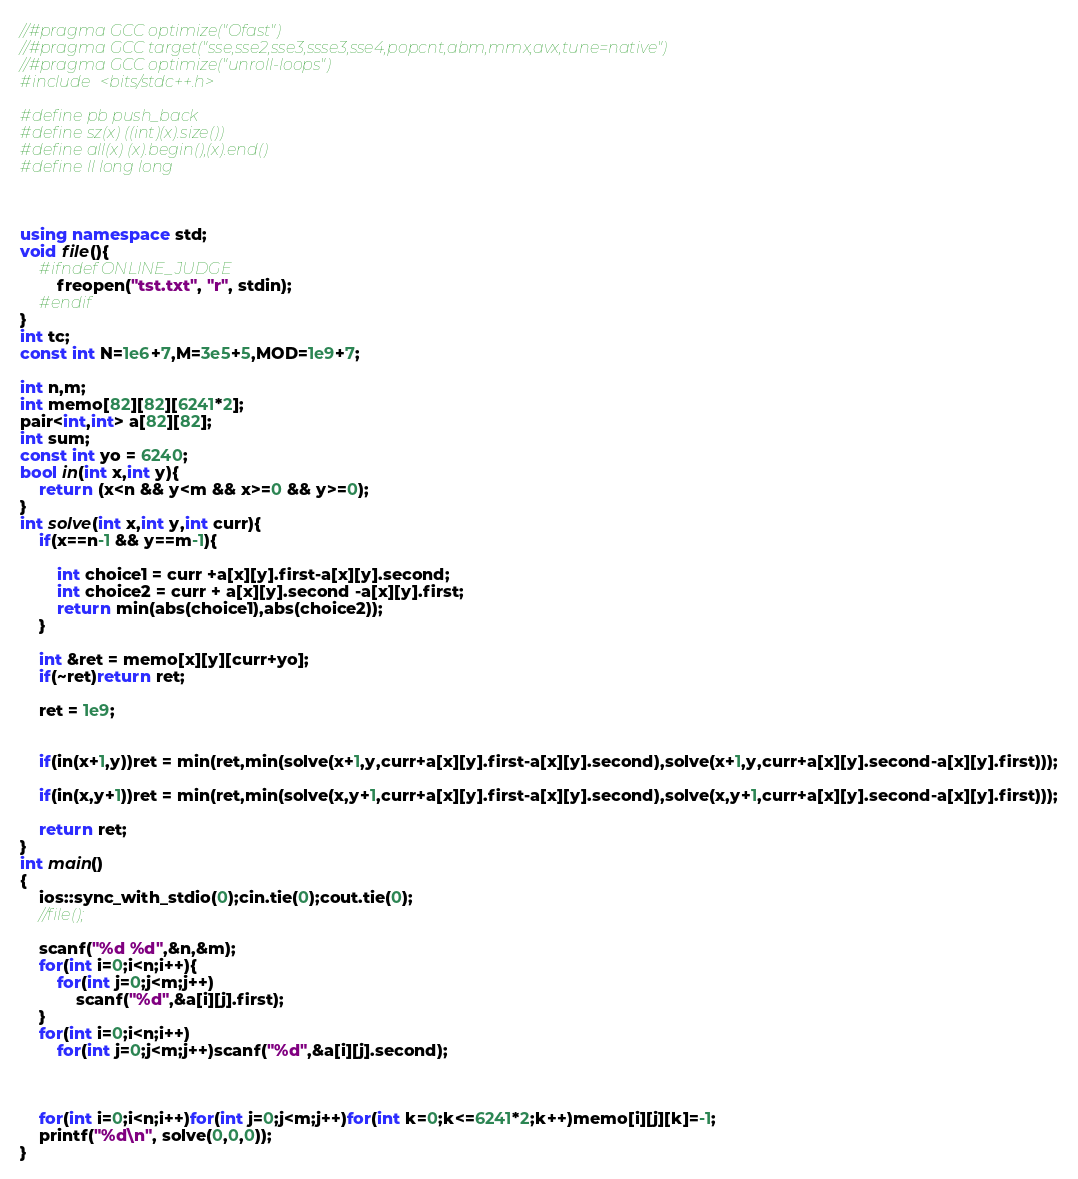Convert code to text. <code><loc_0><loc_0><loc_500><loc_500><_C++_>//#pragma GCC optimize("Ofast")
//#pragma GCC target("sse,sse2,sse3,ssse3,sse4,popcnt,abm,mmx,avx,tune=native")
//#pragma GCC optimize("unroll-loops")
#include <bits/stdc++.h>
 
#define pb push_back
#define sz(x) ((int)(x).size())
#define all(x) (x).begin(),(x).end()
#define ll long long
 
 
 
using namespace std;
void file(){
	#ifndef ONLINE_JUDGE
    	freopen("tst.txt", "r", stdin);
	#endif
}
int tc;
const int N=1e6+7,M=3e5+5,MOD=1e9+7;
 
int n,m;
int memo[82][82][6241*2];
pair<int,int> a[82][82];
int sum;
const int yo = 6240;
bool in(int x,int y){
	return (x<n && y<m && x>=0 && y>=0);
}
int solve(int x,int y,int curr){
	if(x==n-1 && y==m-1){
		
		int choice1 = curr +a[x][y].first-a[x][y].second;
		int choice2 = curr + a[x][y].second -a[x][y].first;
		return min(abs(choice1),abs(choice2));
	}
 
	int &ret = memo[x][y][curr+yo];
	if(~ret)return ret;
	
	ret = 1e9;

	
	if(in(x+1,y))ret = min(ret,min(solve(x+1,y,curr+a[x][y].first-a[x][y].second),solve(x+1,y,curr+a[x][y].second-a[x][y].first)));
	
	if(in(x,y+1))ret = min(ret,min(solve(x,y+1,curr+a[x][y].first-a[x][y].second),solve(x,y+1,curr+a[x][y].second-a[x][y].first)));
 
	return ret;
}
int main()
{
	ios::sync_with_stdio(0);cin.tie(0);cout.tie(0);
	//file();
	
	scanf("%d %d",&n,&m);
	for(int i=0;i<n;i++){
		for(int j=0;j<m;j++)
			scanf("%d",&a[i][j].first);
	}
	for(int i=0;i<n;i++)
		for(int j=0;j<m;j++)scanf("%d",&a[i][j].second);
 	
 	
 	
	for(int i=0;i<n;i++)for(int j=0;j<m;j++)for(int k=0;k<=6241*2;k++)memo[i][j][k]=-1;
	printf("%d\n", solve(0,0,0));
}</code> 